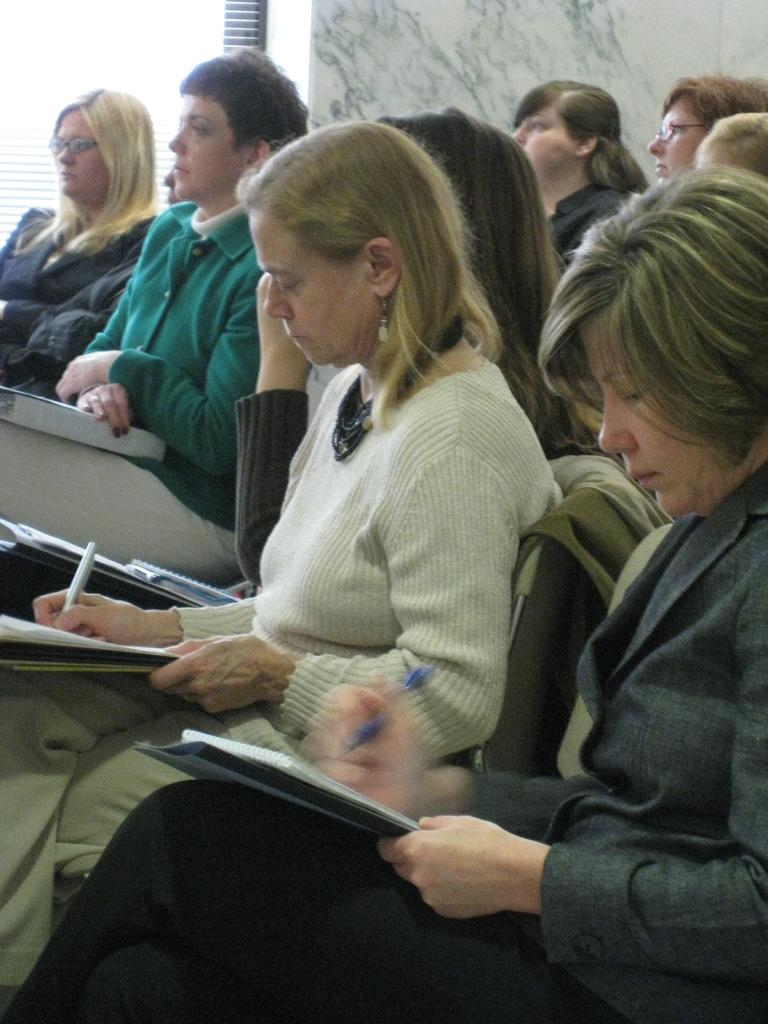What are the people in the foreground of the image doing? The people in the foreground of the image are sitting on chairs. What can be seen in the background of the image? There appears to be a glass window and a marble in the background of the image. How many dinosaurs can be seen in the image? There are no dinosaurs present in the image. What type of insect is crawling on the marble in the image? There is no insect visible on the marble in the image. 